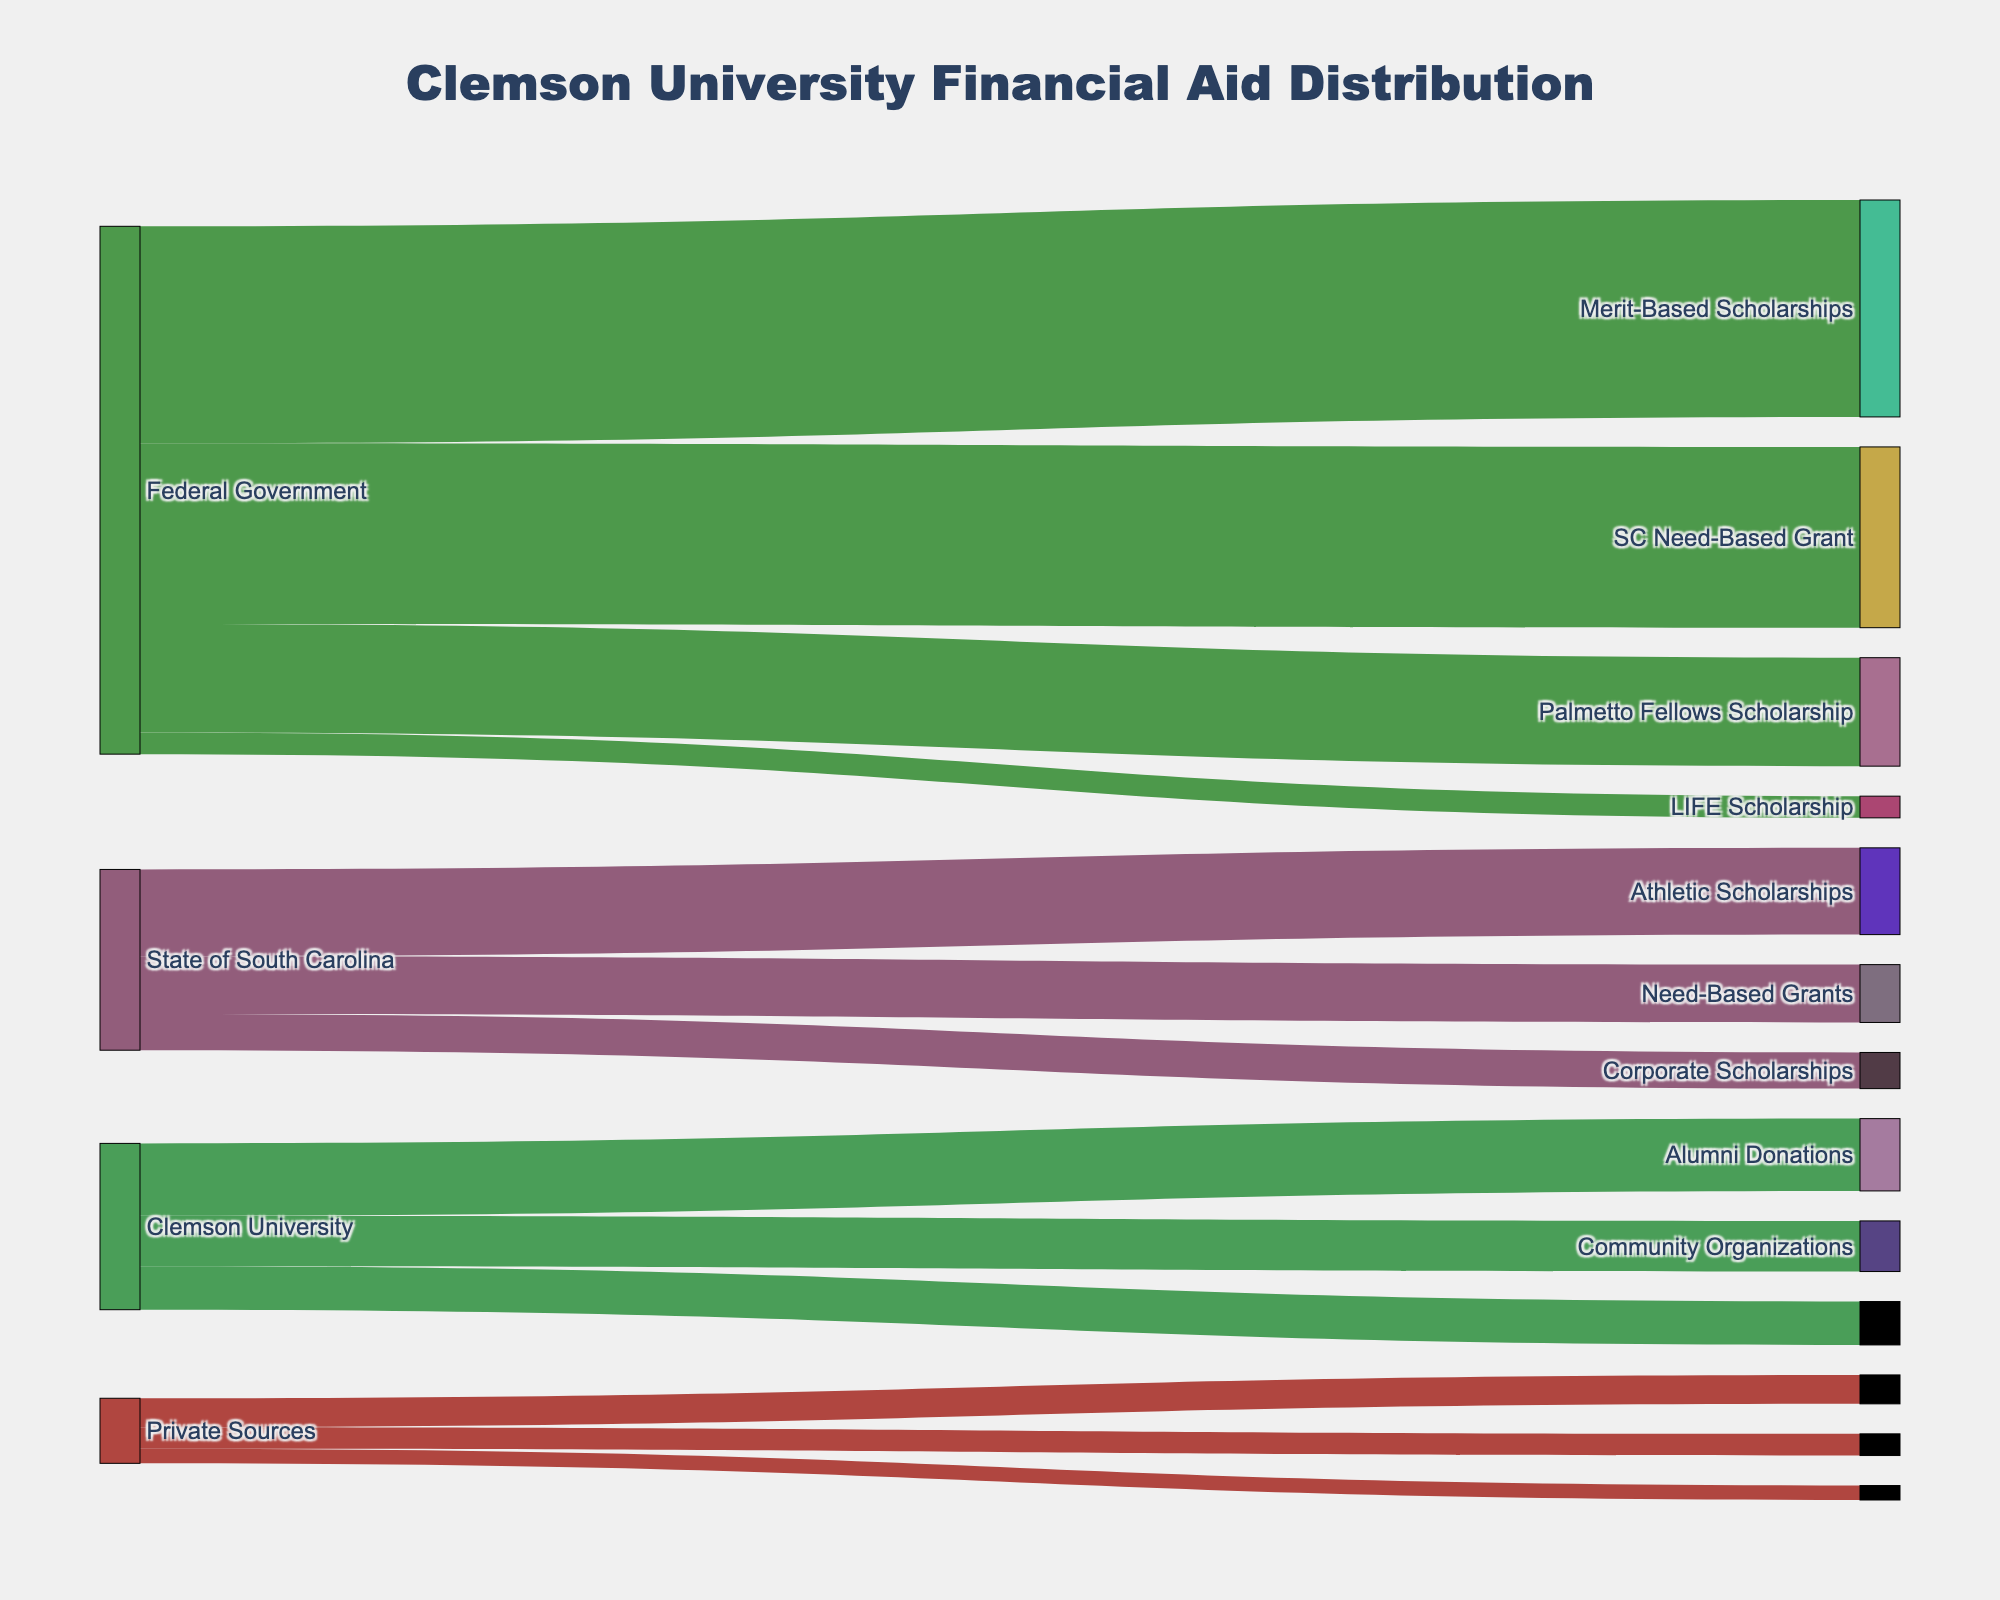What is the total amount of financial aid distributed by the Federal Government? The total amount is the sum of Pell Grants, Work-Study, Direct Subsidized Loans, and Direct Unsubsidized Loans provided by the Federal Government. Adding these amounts gives 15,000,000 + 3,000,000 + 25,000,000 + 30,000,000 = 73,000,000.
Answer: 73,000,000 Which source provides the highest amount of financial aid? By comparing the total amounts from the Federal Government, State of South Carolina, Clemson University, and Private Sources, we can determine the Federal Government distributes the most financial aid by summing its contributions.
Answer: Federal Government How much more financial aid does Clemson University provide in Merit-Based Scholarships compared to Private Sources through Community Organizations? Clemson University provides 10,000,000 in Merit-Based Scholarships, whereas Private Sources provide 2,000,000 through Community Organizations. The difference is 10,000,000 - 2,000,000 = 8,000,000.
Answer: 8,000,000 What is the combined amount of financial aid provided by the State of South Carolina for Palmetto Fellows Scholarship and LIFE Scholarship? Adding the amounts for Palmetto Fellows Scholarship (8,000,000) and LIFE Scholarship (12,000,000) gives a total of 8,000,000 + 12,000,000 = 20,000,000.
Answer: 20,000,000 Which type of financial aid receives the most funding overall? By comparing the amounts received by each type, Direct Unsubsidized Loans have the highest funding at 30,000,000.
Answer: Direct Unsubsidized Loans What is the percentage of total financial aid provided by Clemson University out of the total financial aid amount? First, calculate the total financial aid amount distributed, which is the sum of all entries (73,000,000 from Federal, 25,000,000 from State, 23,000,000 from Clemson, and 9,000,000 from Private Sources). The total is 130,000,000. Then, calculate the percentage provided by Clemson University which is (23,000,000 / 130,000,000) * 100 ≈ 17.69%.
Answer: 17.69% How much financial aid does the State of South Carolina provide compared to Private Sources? The State of South Carolina provides a total of 8,000,000 + 12,000,000 + 5,000,000 = 25,000,000, while Private Sources provide a total of 4,000,000 + 3,000,000 + 2,000,000 = 9,000,000. The difference is 25,000,000 - 9,000,000 = 16,000,000.
Answer: 16,000,000 What proportion of financial aid from Clemson University is Merit-Based Scholarships? The total aid from Clemson University is 23,000,000. Merit-Based Scholarships constitute 10,000,000 of this amount. The proportion is (10,000,000 / 23,000,000) ≈ 0.4348 or 43.48%.
Answer: 43.48% What is the total amount of financial aid provided by Private Sources? The total amount is the sum of Corporate Scholarships, Alumni Donations, and Community Organizations. Adding these amounts gives 4,000,000 + 3,000,000 + 2,000,000 = 9,000,000.
Answer: 9,000,000 What are the three largest types of financial aid provided? By sorting the types of financial aid by amount, the three largest are Direct Unsubsidized Loans (30,000,000), Direct Subsidized Loans (25,000,000), and Pell Grants (15,000,000).
Answer: Direct Unsubsidized Loans, Direct Subsidized Loans, Pell Grants 